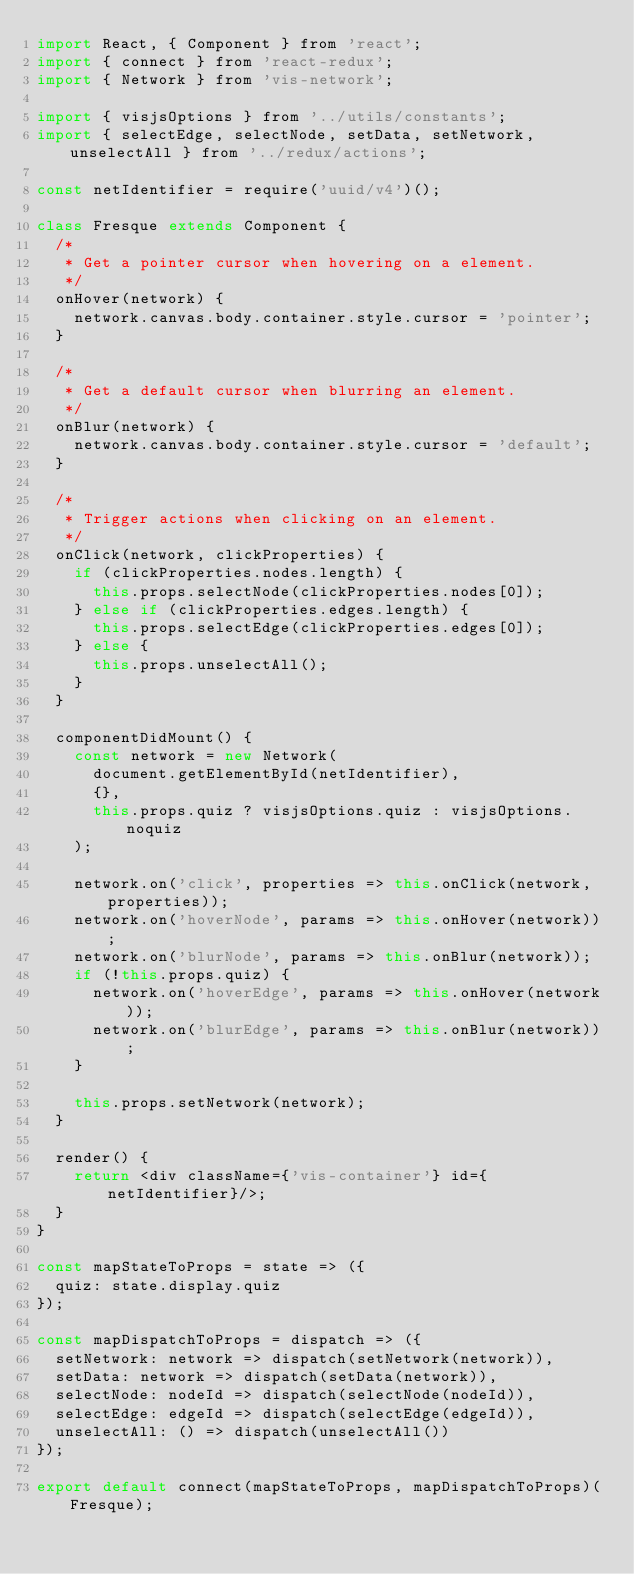Convert code to text. <code><loc_0><loc_0><loc_500><loc_500><_JavaScript_>import React, { Component } from 'react';
import { connect } from 'react-redux';
import { Network } from 'vis-network';

import { visjsOptions } from '../utils/constants';
import { selectEdge, selectNode, setData, setNetwork, unselectAll } from '../redux/actions';

const netIdentifier = require('uuid/v4')();

class Fresque extends Component {
  /*
   * Get a pointer cursor when hovering on a element.
   */
  onHover(network) {
    network.canvas.body.container.style.cursor = 'pointer';
  }

  /*
   * Get a default cursor when blurring an element.
   */
  onBlur(network) {
    network.canvas.body.container.style.cursor = 'default';
  }

  /*
   * Trigger actions when clicking on an element.
   */
  onClick(network, clickProperties) {
    if (clickProperties.nodes.length) {
      this.props.selectNode(clickProperties.nodes[0]);
    } else if (clickProperties.edges.length) {
      this.props.selectEdge(clickProperties.edges[0]);
    } else {
      this.props.unselectAll();
    }
  }

  componentDidMount() {
    const network = new Network(
      document.getElementById(netIdentifier),
      {},
      this.props.quiz ? visjsOptions.quiz : visjsOptions.noquiz
    );

    network.on('click', properties => this.onClick(network, properties));
    network.on('hoverNode', params => this.onHover(network));
    network.on('blurNode', params => this.onBlur(network));
    if (!this.props.quiz) {
      network.on('hoverEdge', params => this.onHover(network));
      network.on('blurEdge', params => this.onBlur(network));
    }

    this.props.setNetwork(network);
  }

  render() {
    return <div className={'vis-container'} id={netIdentifier}/>;
  }
}

const mapStateToProps = state => ({
  quiz: state.display.quiz
});

const mapDispatchToProps = dispatch => ({
  setNetwork: network => dispatch(setNetwork(network)),
  setData: network => dispatch(setData(network)),
  selectNode: nodeId => dispatch(selectNode(nodeId)),
  selectEdge: edgeId => dispatch(selectEdge(edgeId)),
  unselectAll: () => dispatch(unselectAll())
});

export default connect(mapStateToProps, mapDispatchToProps)(Fresque);
</code> 